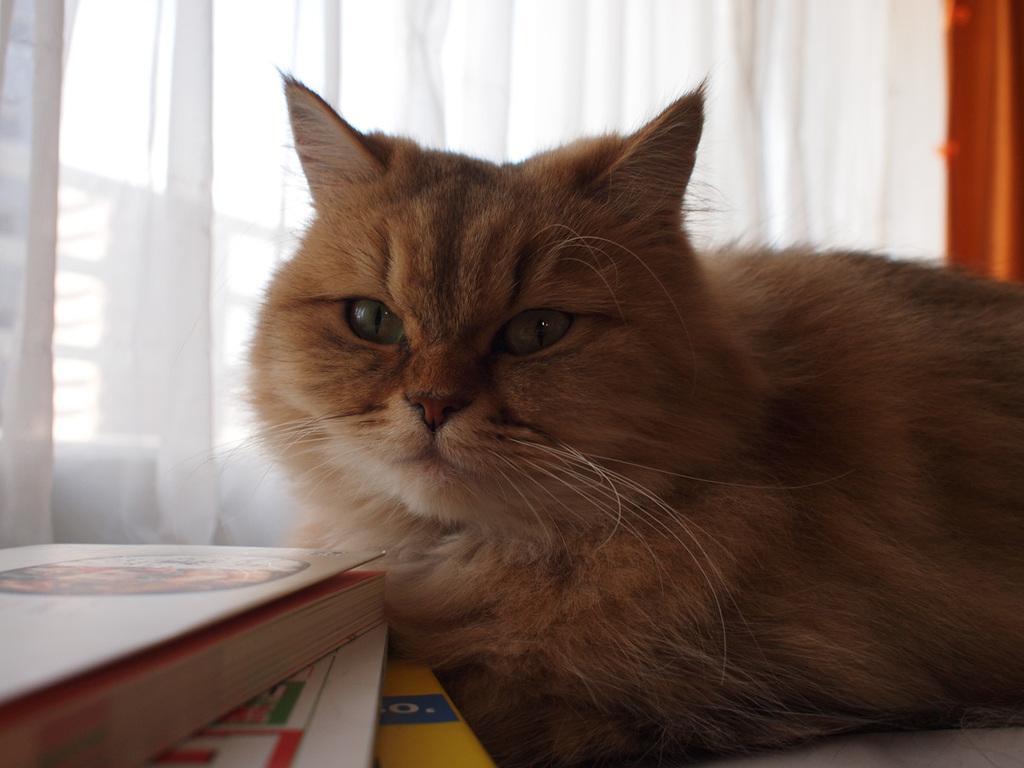In one or two sentences, can you explain what this image depicts? In this image we can see cat. Near to the cat there are books. In the back we can see curtain and windows. 